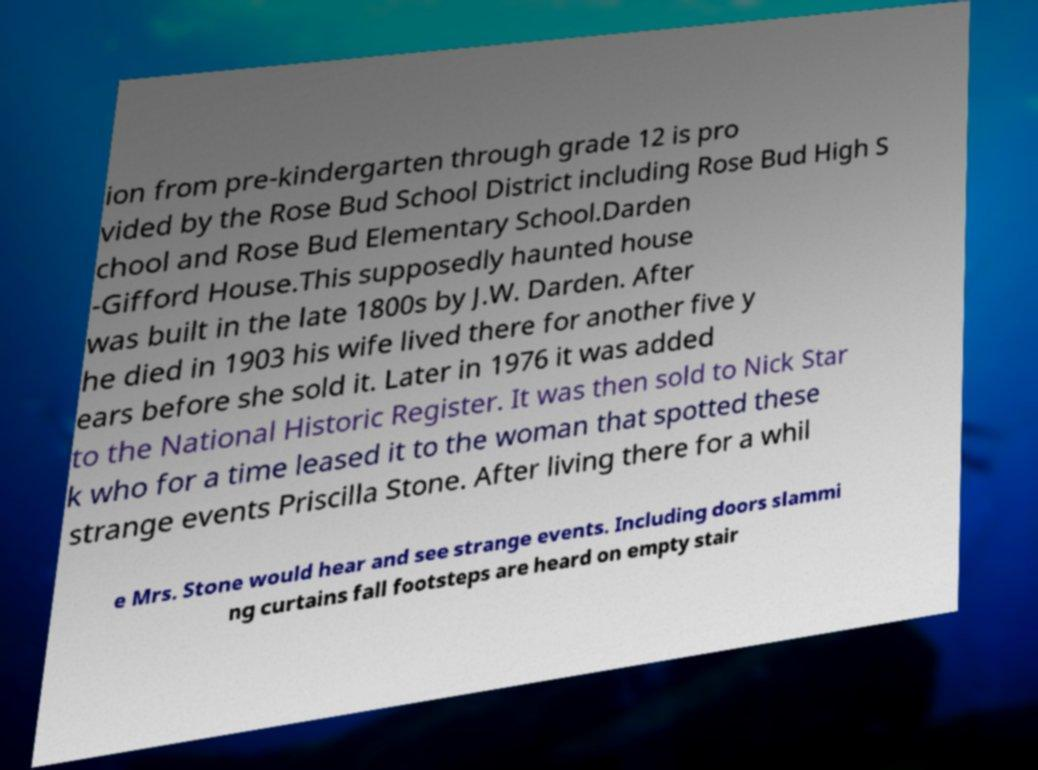Can you read and provide the text displayed in the image?This photo seems to have some interesting text. Can you extract and type it out for me? ion from pre-kindergarten through grade 12 is pro vided by the Rose Bud School District including Rose Bud High S chool and Rose Bud Elementary School.Darden -Gifford House.This supposedly haunted house was built in the late 1800s by J.W. Darden. After he died in 1903 his wife lived there for another five y ears before she sold it. Later in 1976 it was added to the National Historic Register. It was then sold to Nick Star k who for a time leased it to the woman that spotted these strange events Priscilla Stone. After living there for a whil e Mrs. Stone would hear and see strange events. Including doors slammi ng curtains fall footsteps are heard on empty stair 